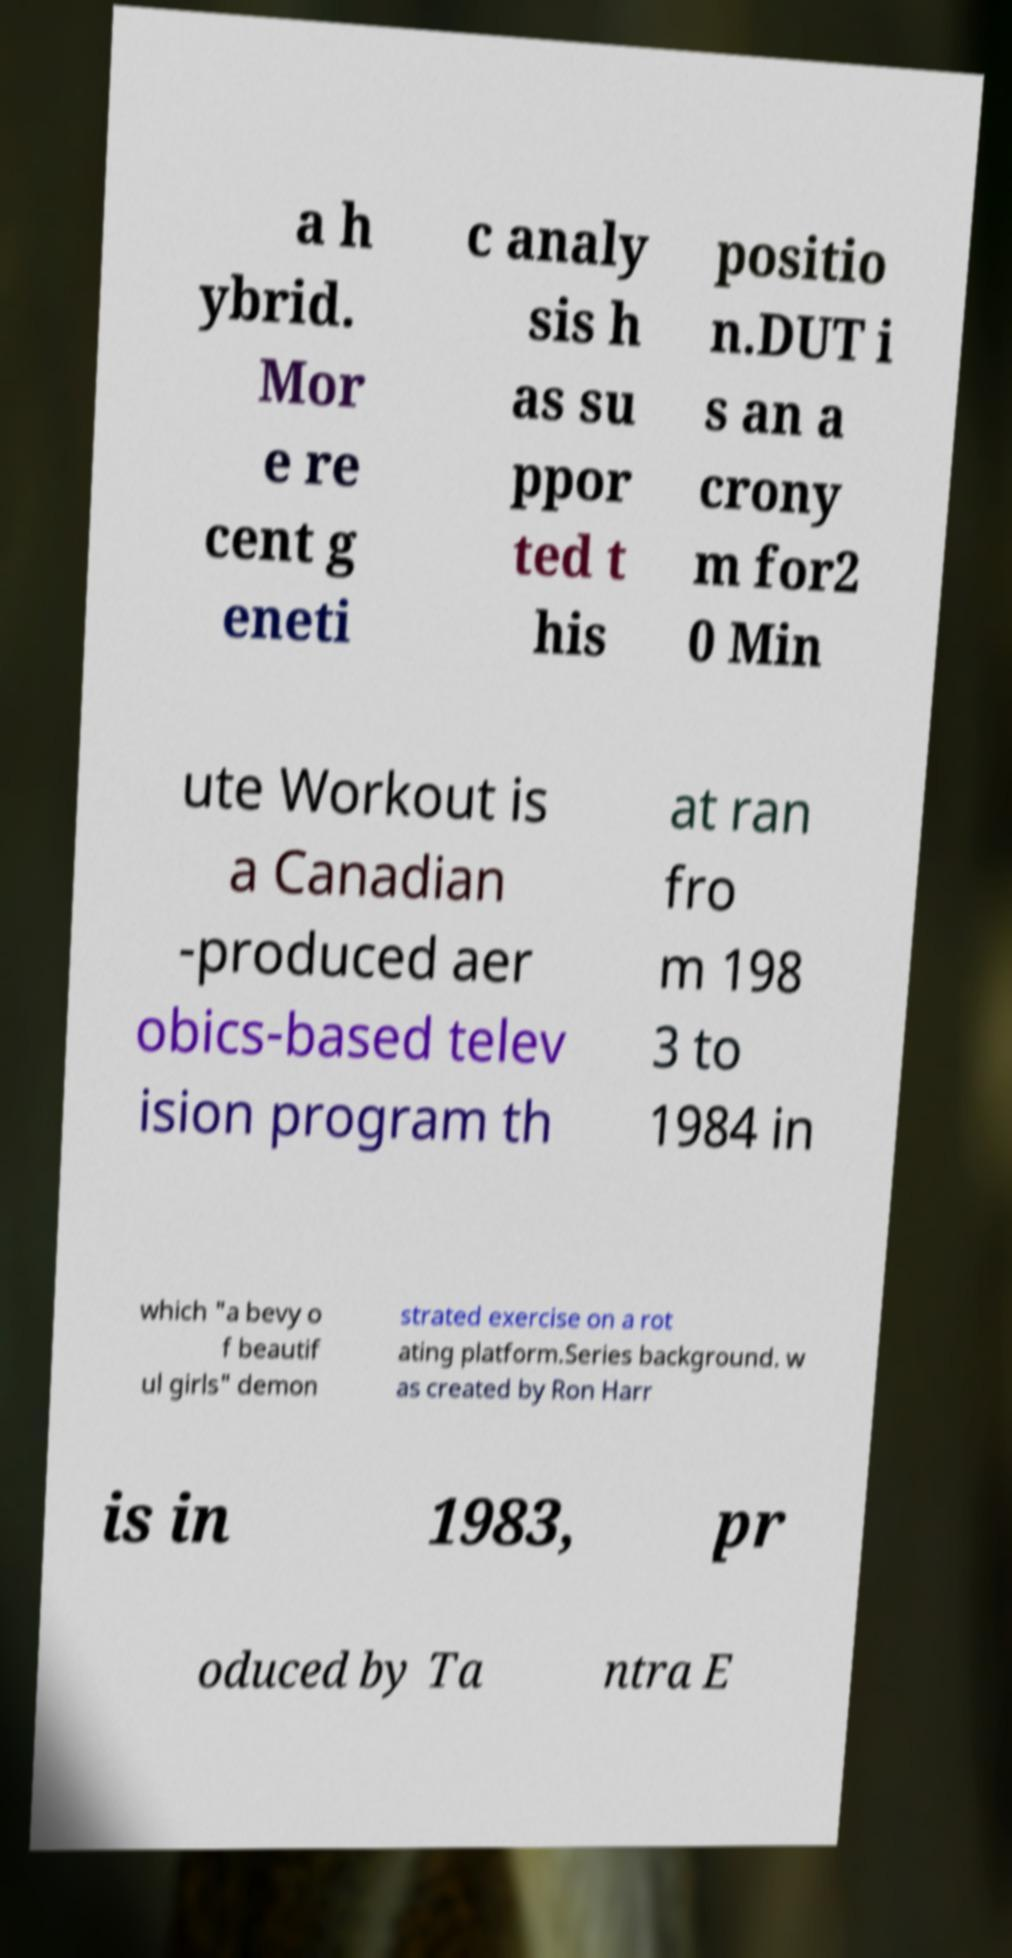Please read and relay the text visible in this image. What does it say? a h ybrid. Mor e re cent g eneti c analy sis h as su ppor ted t his positio n.DUT i s an a crony m for2 0 Min ute Workout is a Canadian -produced aer obics-based telev ision program th at ran fro m 198 3 to 1984 in which "a bevy o f beautif ul girls" demon strated exercise on a rot ating platform.Series background. w as created by Ron Harr is in 1983, pr oduced by Ta ntra E 